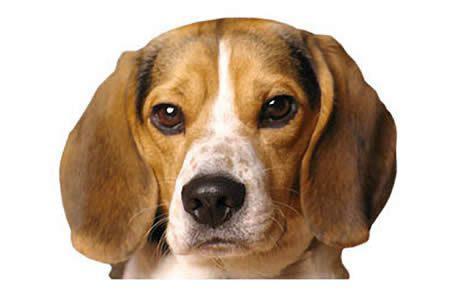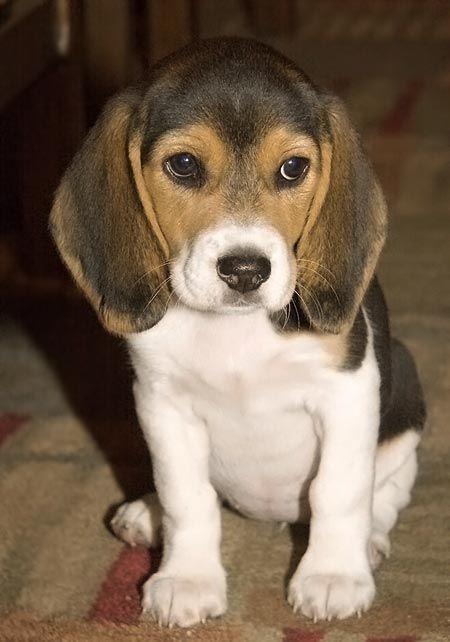The first image is the image on the left, the second image is the image on the right. Analyze the images presented: Is the assertion "One dog has a black 'mask' around its eyes, and one of the dogs has a longer muzzle than the other dog." valid? Answer yes or no. No. The first image is the image on the left, the second image is the image on the right. Given the left and right images, does the statement "The dog in the image on the right has a predominately black head." hold true? Answer yes or no. No. 